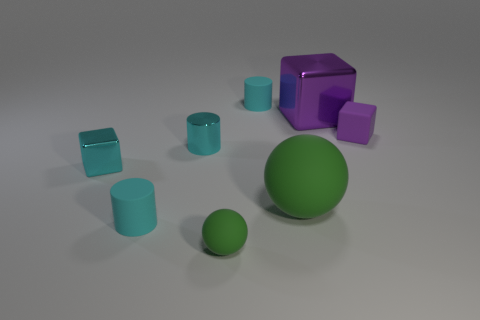How does the size comparison between the green sphere and the other objects help understand the scale of this scene? The green sphere provides a useful reference point for scale. Its size relative to the other objects suggests a staged arrangement with a variety of dimensions to give a sense of depth and perspective. 